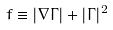Convert formula to latex. <formula><loc_0><loc_0><loc_500><loc_500>f \equiv | \nabla \Gamma | + | \Gamma | ^ { 2 }</formula> 